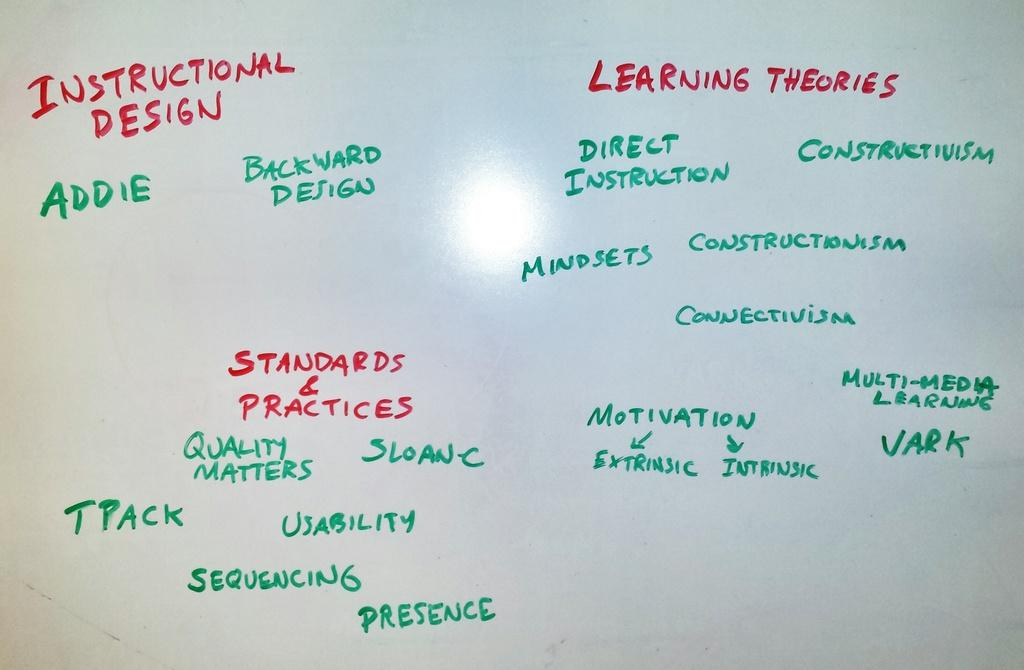<image>
Create a compact narrative representing the image presented. A while board listing Instructional design, learning theories and standards and practices. 